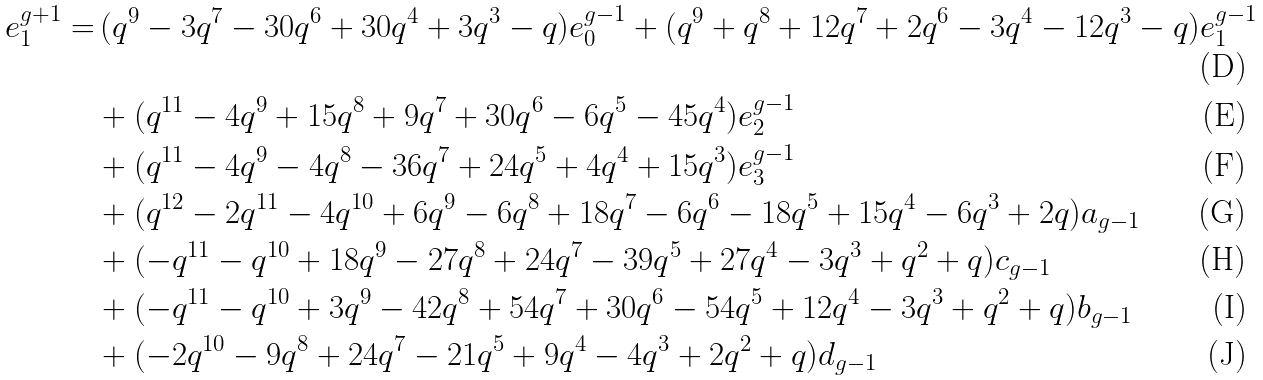Convert formula to latex. <formula><loc_0><loc_0><loc_500><loc_500>e _ { 1 } ^ { g + 1 } = & \, ( q ^ { 9 } - 3 q ^ { 7 } - 3 0 q ^ { 6 } + 3 0 q ^ { 4 } + 3 q ^ { 3 } - q ) e _ { 0 } ^ { g - 1 } + ( q ^ { 9 } + q ^ { 8 } + 1 2 q ^ { 7 } + 2 q ^ { 6 } - 3 q ^ { 4 } - 1 2 q ^ { 3 } - q ) e _ { 1 } ^ { g - 1 } \\ & + ( q ^ { 1 1 } - 4 q ^ { 9 } + 1 5 q ^ { 8 } + 9 q ^ { 7 } + 3 0 q ^ { 6 } - 6 q ^ { 5 } - 4 5 q ^ { 4 } ) e _ { 2 } ^ { g - 1 } \\ & + ( q ^ { 1 1 } - 4 q ^ { 9 } - 4 q ^ { 8 } - 3 6 q ^ { 7 } + 2 4 q ^ { 5 } + 4 q ^ { 4 } + 1 5 q ^ { 3 } ) e _ { 3 } ^ { g - 1 } \\ & + ( q ^ { 1 2 } - 2 q ^ { 1 1 } - 4 q ^ { 1 0 } + 6 q ^ { 9 } - 6 q ^ { 8 } + 1 8 q ^ { 7 } - 6 q ^ { 6 } - 1 8 q ^ { 5 } + 1 5 q ^ { 4 } - 6 q ^ { 3 } + 2 q ) a _ { g - 1 } \\ & + ( - q ^ { 1 1 } - q ^ { 1 0 } + 1 8 q ^ { 9 } - 2 7 q ^ { 8 } + 2 4 q ^ { 7 } - 3 9 q ^ { 5 } + 2 7 q ^ { 4 } - 3 q ^ { 3 } + q ^ { 2 } + q ) c _ { g - 1 } \\ & + ( - q ^ { 1 1 } - q ^ { 1 0 } + 3 q ^ { 9 } - 4 2 q ^ { 8 } + 5 4 q ^ { 7 } + 3 0 q ^ { 6 } - 5 4 q ^ { 5 } + 1 2 q ^ { 4 } - 3 q ^ { 3 } + q ^ { 2 } + q ) b _ { g - 1 } \\ & + ( - 2 q ^ { 1 0 } - 9 q ^ { 8 } + 2 4 q ^ { 7 } - 2 1 q ^ { 5 } + 9 q ^ { 4 } - 4 q ^ { 3 } + 2 q ^ { 2 } + q ) d _ { g - 1 }</formula> 